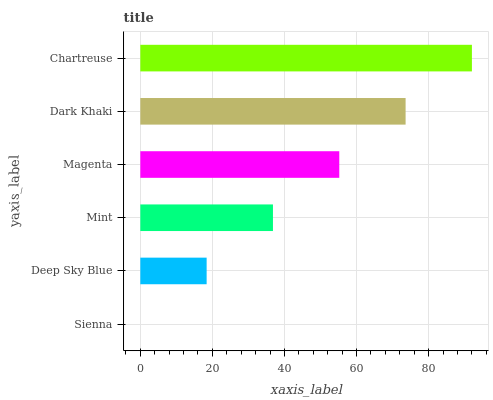Is Sienna the minimum?
Answer yes or no. Yes. Is Chartreuse the maximum?
Answer yes or no. Yes. Is Deep Sky Blue the minimum?
Answer yes or no. No. Is Deep Sky Blue the maximum?
Answer yes or no. No. Is Deep Sky Blue greater than Sienna?
Answer yes or no. Yes. Is Sienna less than Deep Sky Blue?
Answer yes or no. Yes. Is Sienna greater than Deep Sky Blue?
Answer yes or no. No. Is Deep Sky Blue less than Sienna?
Answer yes or no. No. Is Magenta the high median?
Answer yes or no. Yes. Is Mint the low median?
Answer yes or no. Yes. Is Mint the high median?
Answer yes or no. No. Is Chartreuse the low median?
Answer yes or no. No. 